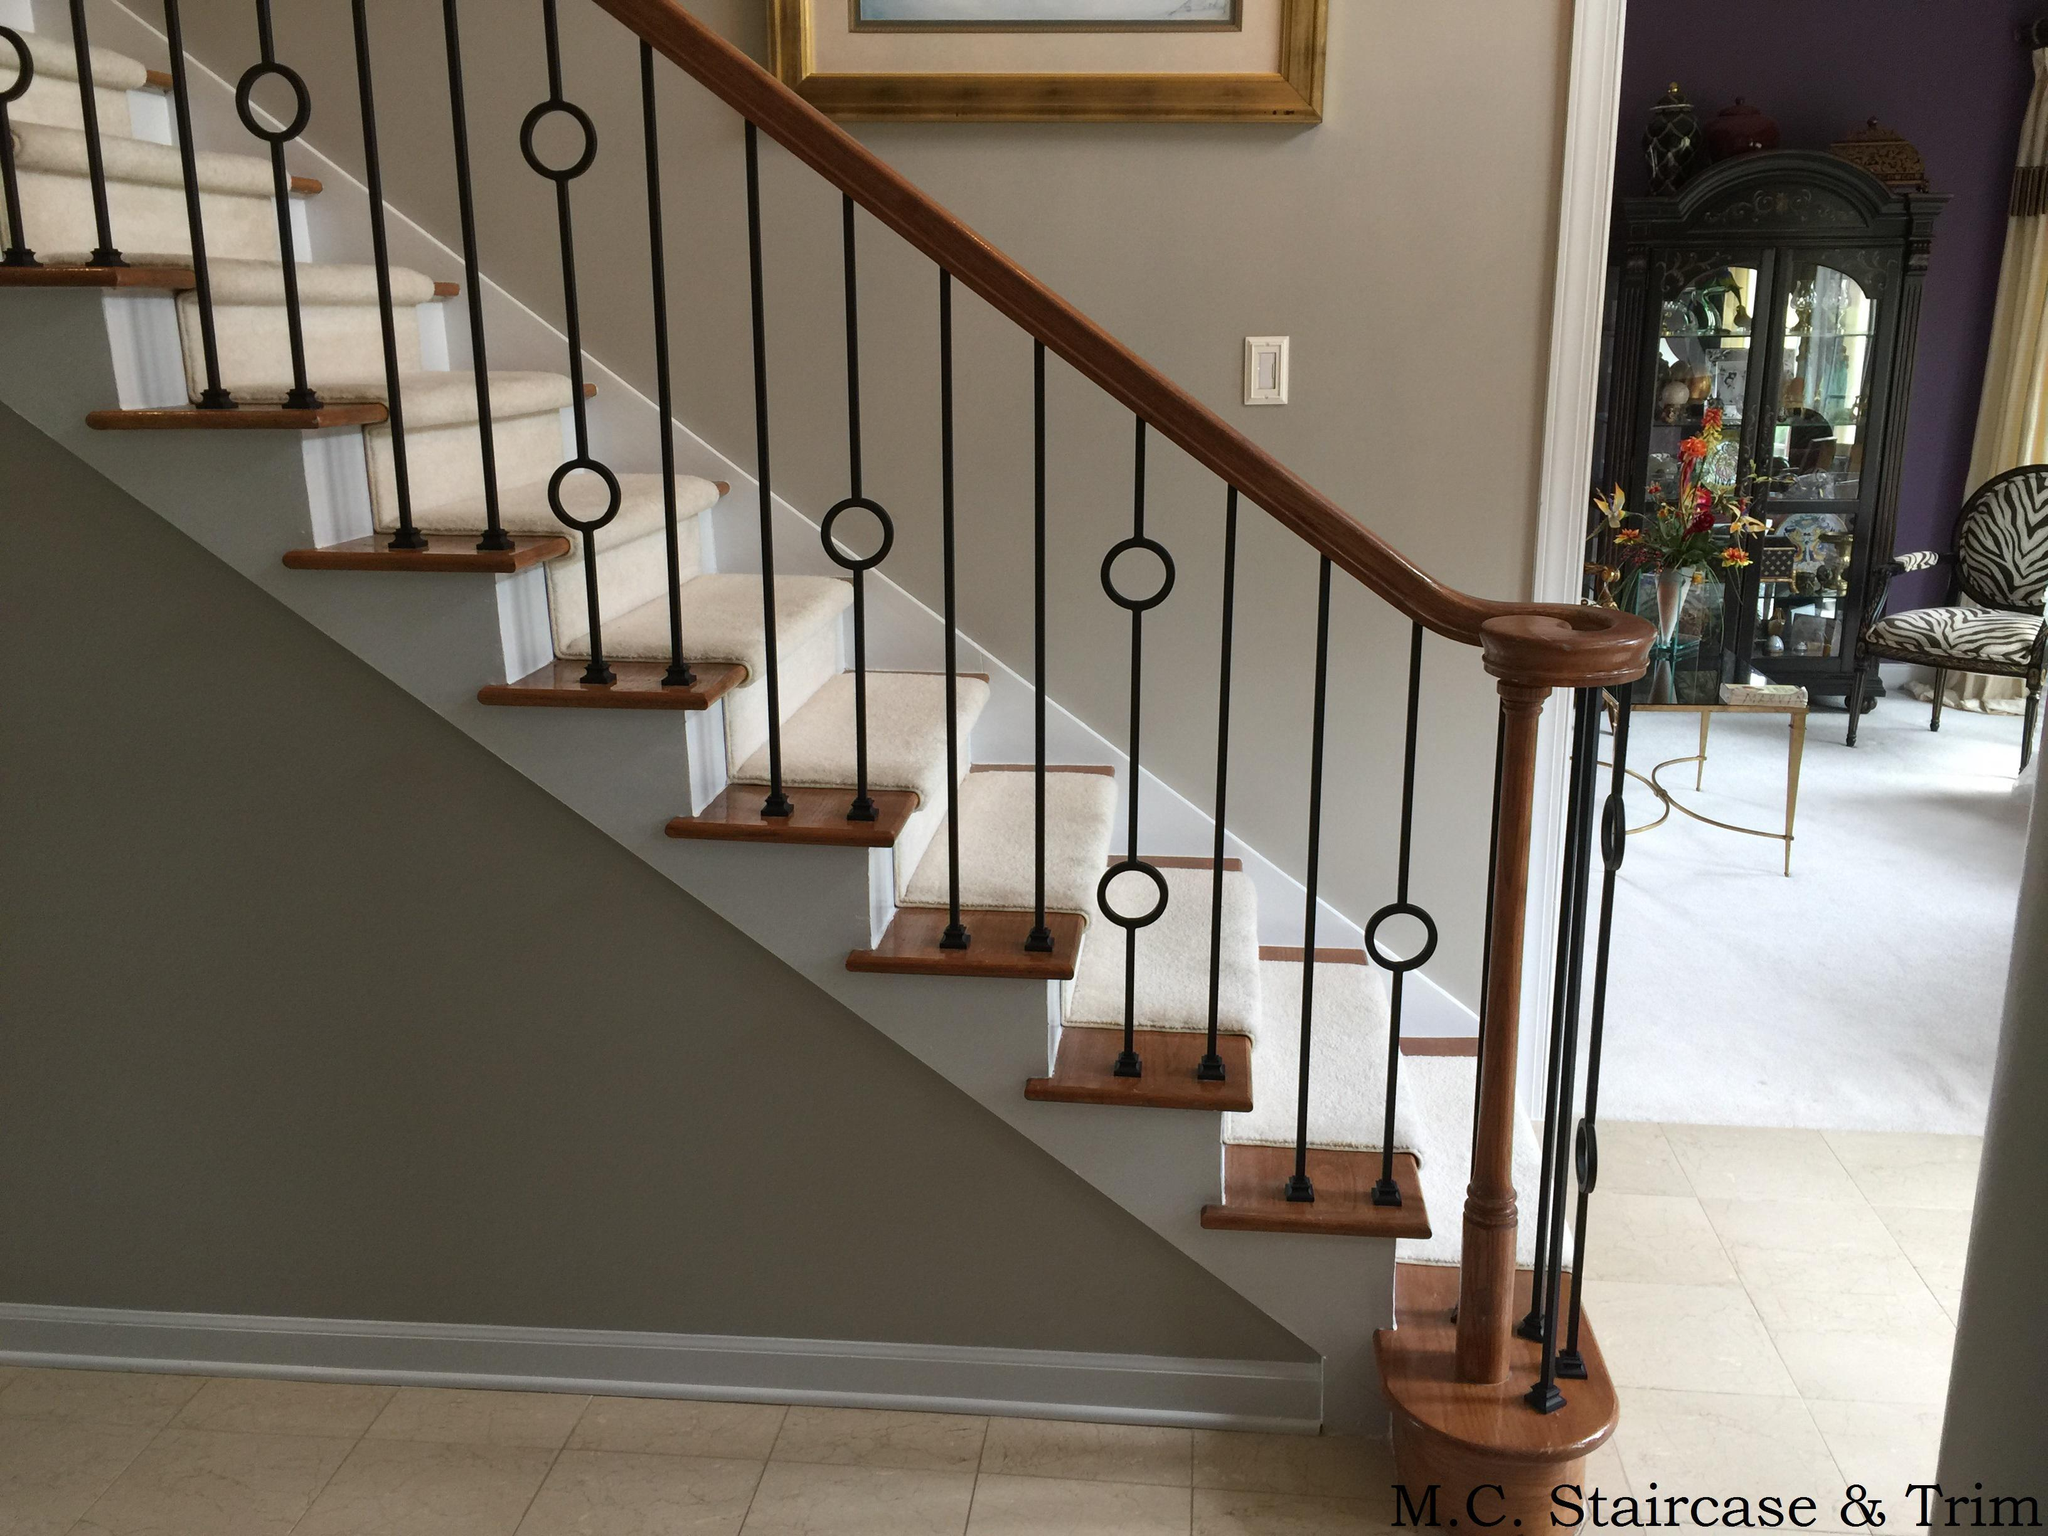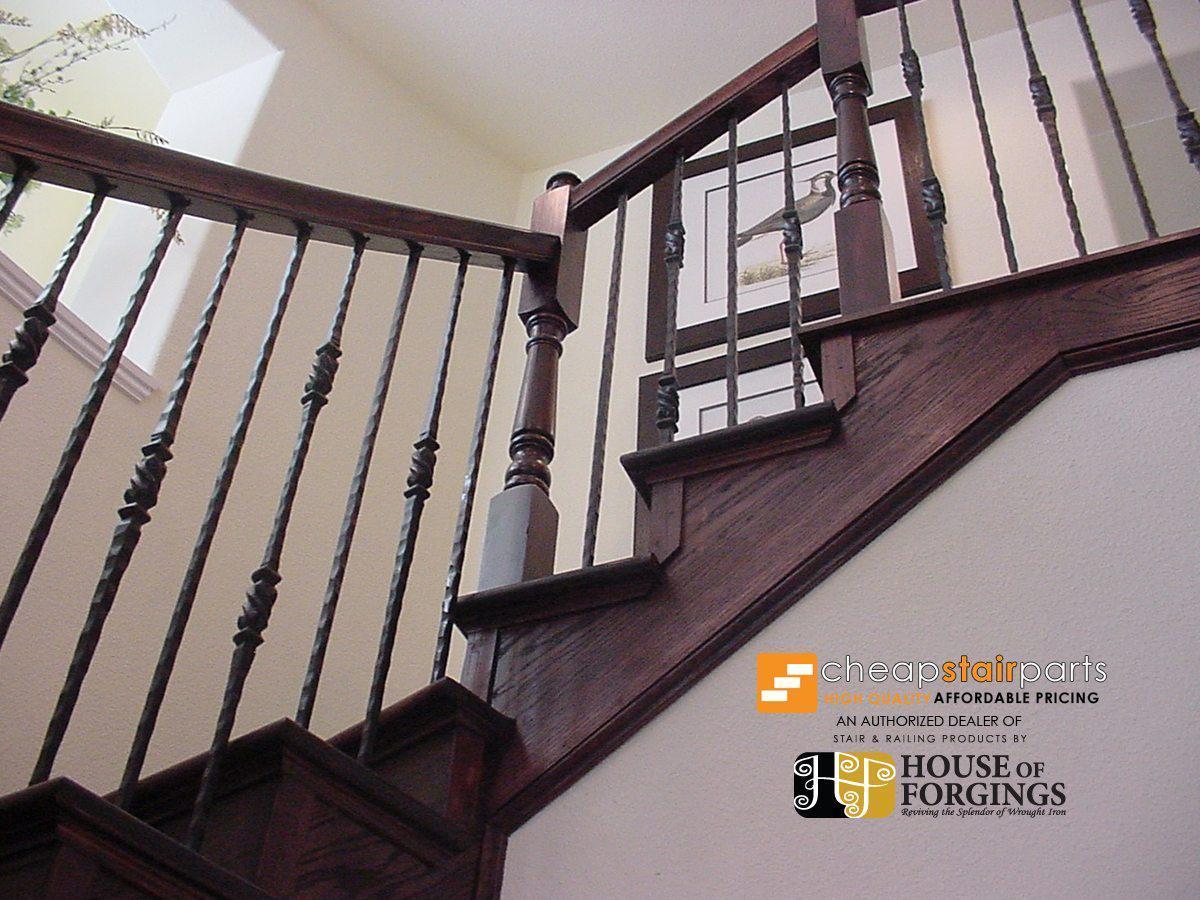The first image is the image on the left, the second image is the image on the right. Considering the images on both sides, is "The stairway in the right image goes straight." valid? Answer yes or no. No. 